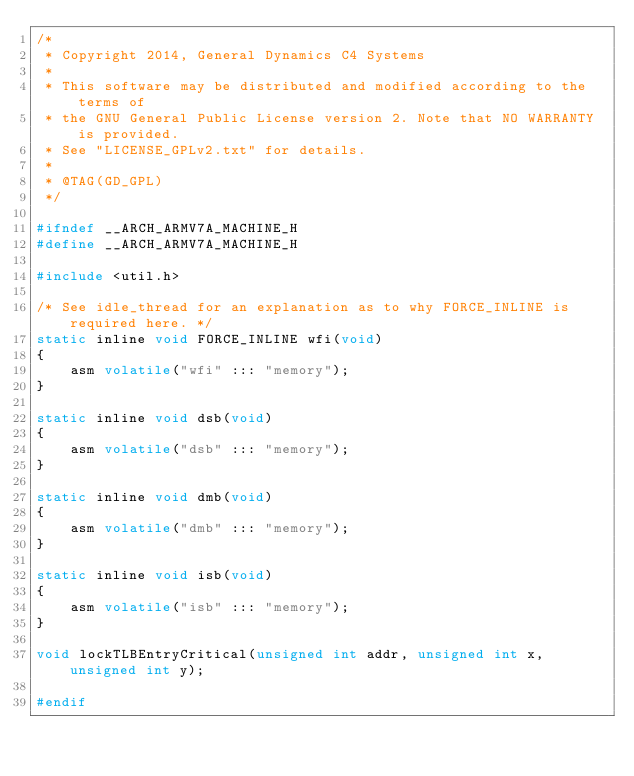<code> <loc_0><loc_0><loc_500><loc_500><_C_>/*
 * Copyright 2014, General Dynamics C4 Systems
 *
 * This software may be distributed and modified according to the terms of
 * the GNU General Public License version 2. Note that NO WARRANTY is provided.
 * See "LICENSE_GPLv2.txt" for details.
 *
 * @TAG(GD_GPL)
 */

#ifndef __ARCH_ARMV7A_MACHINE_H
#define __ARCH_ARMV7A_MACHINE_H

#include <util.h>

/* See idle_thread for an explanation as to why FORCE_INLINE is required here. */
static inline void FORCE_INLINE wfi(void)
{
    asm volatile("wfi" ::: "memory");
}

static inline void dsb(void)
{
    asm volatile("dsb" ::: "memory");
}

static inline void dmb(void)
{
    asm volatile("dmb" ::: "memory");
}

static inline void isb(void)
{
    asm volatile("isb" ::: "memory");
}

void lockTLBEntryCritical(unsigned int addr, unsigned int x, unsigned int y);

#endif
</code> 